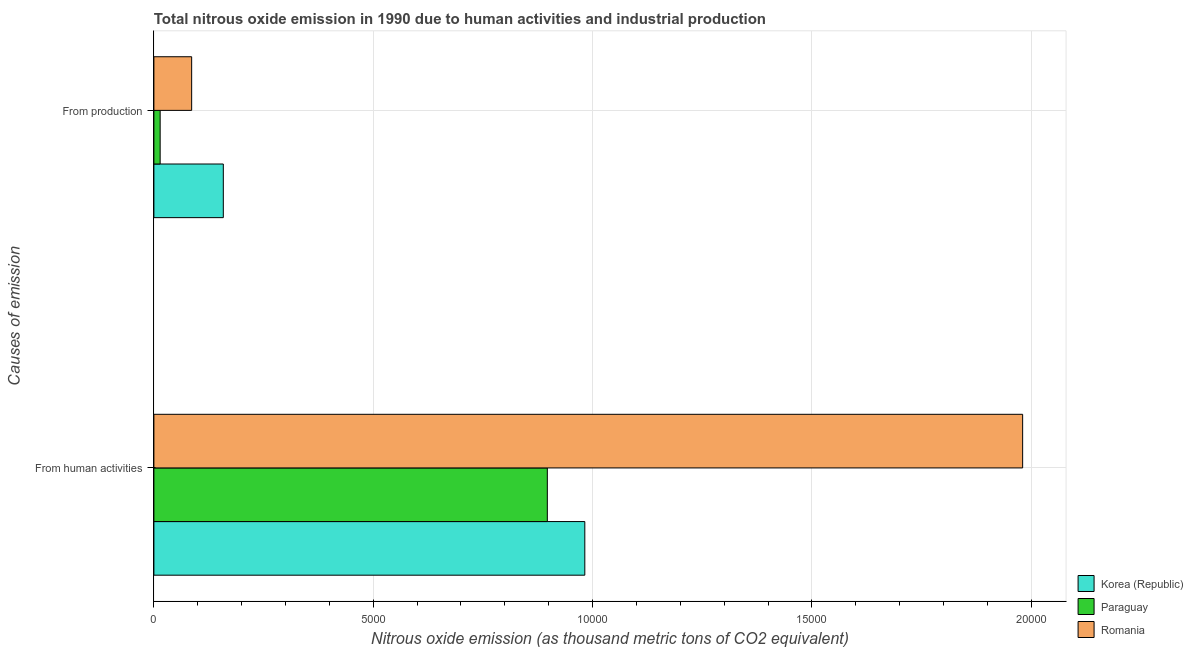How many different coloured bars are there?
Give a very brief answer. 3. Are the number of bars on each tick of the Y-axis equal?
Offer a very short reply. Yes. What is the label of the 2nd group of bars from the top?
Your response must be concise. From human activities. What is the amount of emissions generated from industries in Paraguay?
Make the answer very short. 143. Across all countries, what is the maximum amount of emissions generated from industries?
Keep it short and to the point. 1582.6. Across all countries, what is the minimum amount of emissions generated from industries?
Ensure brevity in your answer.  143. In which country was the amount of emissions from human activities maximum?
Your response must be concise. Romania. In which country was the amount of emissions generated from industries minimum?
Make the answer very short. Paraguay. What is the total amount of emissions from human activities in the graph?
Provide a succinct answer. 3.86e+04. What is the difference between the amount of emissions from human activities in Korea (Republic) and that in Romania?
Your answer should be very brief. -9980.4. What is the difference between the amount of emissions from human activities in Paraguay and the amount of emissions generated from industries in Korea (Republic)?
Provide a succinct answer. 7386.1. What is the average amount of emissions from human activities per country?
Keep it short and to the point. 1.29e+04. What is the difference between the amount of emissions from human activities and amount of emissions generated from industries in Romania?
Offer a terse response. 1.89e+04. In how many countries, is the amount of emissions generated from industries greater than 4000 thousand metric tons?
Ensure brevity in your answer.  0. What is the ratio of the amount of emissions generated from industries in Korea (Republic) to that in Paraguay?
Your answer should be compact. 11.07. What does the 2nd bar from the top in From human activities represents?
Provide a short and direct response. Paraguay. How many bars are there?
Offer a very short reply. 6. How many countries are there in the graph?
Your answer should be very brief. 3. What is the difference between two consecutive major ticks on the X-axis?
Your response must be concise. 5000. Does the graph contain any zero values?
Ensure brevity in your answer.  No. Does the graph contain grids?
Ensure brevity in your answer.  Yes. How many legend labels are there?
Your answer should be compact. 3. How are the legend labels stacked?
Provide a short and direct response. Vertical. What is the title of the graph?
Your response must be concise. Total nitrous oxide emission in 1990 due to human activities and industrial production. What is the label or title of the X-axis?
Provide a short and direct response. Nitrous oxide emission (as thousand metric tons of CO2 equivalent). What is the label or title of the Y-axis?
Your response must be concise. Causes of emission. What is the Nitrous oxide emission (as thousand metric tons of CO2 equivalent) in Korea (Republic) in From human activities?
Keep it short and to the point. 9823.4. What is the Nitrous oxide emission (as thousand metric tons of CO2 equivalent) in Paraguay in From human activities?
Ensure brevity in your answer.  8968.7. What is the Nitrous oxide emission (as thousand metric tons of CO2 equivalent) of Romania in From human activities?
Your answer should be compact. 1.98e+04. What is the Nitrous oxide emission (as thousand metric tons of CO2 equivalent) of Korea (Republic) in From production?
Offer a terse response. 1582.6. What is the Nitrous oxide emission (as thousand metric tons of CO2 equivalent) of Paraguay in From production?
Provide a short and direct response. 143. What is the Nitrous oxide emission (as thousand metric tons of CO2 equivalent) of Romania in From production?
Keep it short and to the point. 861.1. Across all Causes of emission, what is the maximum Nitrous oxide emission (as thousand metric tons of CO2 equivalent) of Korea (Republic)?
Offer a very short reply. 9823.4. Across all Causes of emission, what is the maximum Nitrous oxide emission (as thousand metric tons of CO2 equivalent) in Paraguay?
Make the answer very short. 8968.7. Across all Causes of emission, what is the maximum Nitrous oxide emission (as thousand metric tons of CO2 equivalent) of Romania?
Provide a succinct answer. 1.98e+04. Across all Causes of emission, what is the minimum Nitrous oxide emission (as thousand metric tons of CO2 equivalent) of Korea (Republic)?
Your answer should be very brief. 1582.6. Across all Causes of emission, what is the minimum Nitrous oxide emission (as thousand metric tons of CO2 equivalent) in Paraguay?
Your answer should be very brief. 143. Across all Causes of emission, what is the minimum Nitrous oxide emission (as thousand metric tons of CO2 equivalent) in Romania?
Your answer should be compact. 861.1. What is the total Nitrous oxide emission (as thousand metric tons of CO2 equivalent) in Korea (Republic) in the graph?
Offer a very short reply. 1.14e+04. What is the total Nitrous oxide emission (as thousand metric tons of CO2 equivalent) in Paraguay in the graph?
Ensure brevity in your answer.  9111.7. What is the total Nitrous oxide emission (as thousand metric tons of CO2 equivalent) in Romania in the graph?
Ensure brevity in your answer.  2.07e+04. What is the difference between the Nitrous oxide emission (as thousand metric tons of CO2 equivalent) in Korea (Republic) in From human activities and that in From production?
Your answer should be very brief. 8240.8. What is the difference between the Nitrous oxide emission (as thousand metric tons of CO2 equivalent) of Paraguay in From human activities and that in From production?
Your response must be concise. 8825.7. What is the difference between the Nitrous oxide emission (as thousand metric tons of CO2 equivalent) in Romania in From human activities and that in From production?
Ensure brevity in your answer.  1.89e+04. What is the difference between the Nitrous oxide emission (as thousand metric tons of CO2 equivalent) of Korea (Republic) in From human activities and the Nitrous oxide emission (as thousand metric tons of CO2 equivalent) of Paraguay in From production?
Offer a very short reply. 9680.4. What is the difference between the Nitrous oxide emission (as thousand metric tons of CO2 equivalent) of Korea (Republic) in From human activities and the Nitrous oxide emission (as thousand metric tons of CO2 equivalent) of Romania in From production?
Your answer should be very brief. 8962.3. What is the difference between the Nitrous oxide emission (as thousand metric tons of CO2 equivalent) in Paraguay in From human activities and the Nitrous oxide emission (as thousand metric tons of CO2 equivalent) in Romania in From production?
Provide a succinct answer. 8107.6. What is the average Nitrous oxide emission (as thousand metric tons of CO2 equivalent) in Korea (Republic) per Causes of emission?
Provide a succinct answer. 5703. What is the average Nitrous oxide emission (as thousand metric tons of CO2 equivalent) of Paraguay per Causes of emission?
Offer a very short reply. 4555.85. What is the average Nitrous oxide emission (as thousand metric tons of CO2 equivalent) of Romania per Causes of emission?
Make the answer very short. 1.03e+04. What is the difference between the Nitrous oxide emission (as thousand metric tons of CO2 equivalent) in Korea (Republic) and Nitrous oxide emission (as thousand metric tons of CO2 equivalent) in Paraguay in From human activities?
Your answer should be compact. 854.7. What is the difference between the Nitrous oxide emission (as thousand metric tons of CO2 equivalent) in Korea (Republic) and Nitrous oxide emission (as thousand metric tons of CO2 equivalent) in Romania in From human activities?
Your answer should be very brief. -9980.4. What is the difference between the Nitrous oxide emission (as thousand metric tons of CO2 equivalent) of Paraguay and Nitrous oxide emission (as thousand metric tons of CO2 equivalent) of Romania in From human activities?
Offer a very short reply. -1.08e+04. What is the difference between the Nitrous oxide emission (as thousand metric tons of CO2 equivalent) in Korea (Republic) and Nitrous oxide emission (as thousand metric tons of CO2 equivalent) in Paraguay in From production?
Give a very brief answer. 1439.6. What is the difference between the Nitrous oxide emission (as thousand metric tons of CO2 equivalent) in Korea (Republic) and Nitrous oxide emission (as thousand metric tons of CO2 equivalent) in Romania in From production?
Your answer should be compact. 721.5. What is the difference between the Nitrous oxide emission (as thousand metric tons of CO2 equivalent) in Paraguay and Nitrous oxide emission (as thousand metric tons of CO2 equivalent) in Romania in From production?
Keep it short and to the point. -718.1. What is the ratio of the Nitrous oxide emission (as thousand metric tons of CO2 equivalent) in Korea (Republic) in From human activities to that in From production?
Keep it short and to the point. 6.21. What is the ratio of the Nitrous oxide emission (as thousand metric tons of CO2 equivalent) of Paraguay in From human activities to that in From production?
Provide a short and direct response. 62.72. What is the ratio of the Nitrous oxide emission (as thousand metric tons of CO2 equivalent) of Romania in From human activities to that in From production?
Provide a succinct answer. 23. What is the difference between the highest and the second highest Nitrous oxide emission (as thousand metric tons of CO2 equivalent) in Korea (Republic)?
Ensure brevity in your answer.  8240.8. What is the difference between the highest and the second highest Nitrous oxide emission (as thousand metric tons of CO2 equivalent) in Paraguay?
Provide a short and direct response. 8825.7. What is the difference between the highest and the second highest Nitrous oxide emission (as thousand metric tons of CO2 equivalent) of Romania?
Your answer should be compact. 1.89e+04. What is the difference between the highest and the lowest Nitrous oxide emission (as thousand metric tons of CO2 equivalent) of Korea (Republic)?
Offer a very short reply. 8240.8. What is the difference between the highest and the lowest Nitrous oxide emission (as thousand metric tons of CO2 equivalent) in Paraguay?
Your answer should be very brief. 8825.7. What is the difference between the highest and the lowest Nitrous oxide emission (as thousand metric tons of CO2 equivalent) in Romania?
Your answer should be compact. 1.89e+04. 